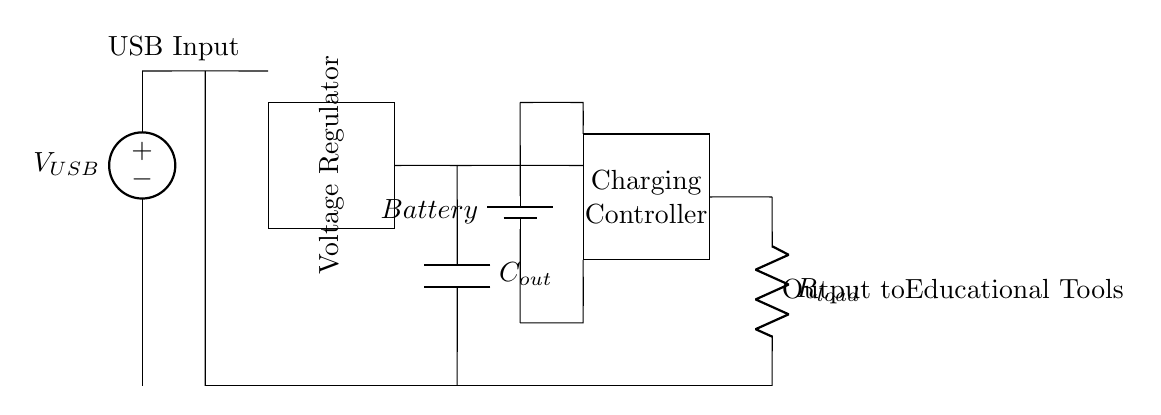What is the function of the component labeled "Voltage Regulator"? The Voltage Regulator ensures that the voltage supplied to the rest of the circuit remains constant, typically regulating it to a specific level suitable for charging or powering connected devices.
Answer: Voltage regulation What type of power source does the circuit use? The circuit uses a USB power source, which is indicated by the "USB Input" label, showing that it is designed to receive power from a USB connection.
Answer: USB How many main components are there in this charging circuit? The main components include the USB input, voltage regulator, battery, charging controller, output capacitor, and load resistor. Counting these reveals a total of five main components in the circuit.
Answer: Five What connects the output capacitor to the battery? The output capacitor is connected to the battery via the charging controller, which regulates the charging process from the capacitor to the battery.
Answer: Charging controller What is the role of the "Charging Controller"? The Charging Controller manages the charging process, controlling how current flows from the USB input and output capacitor to the battery, ensuring safe and efficient charging.
Answer: Battery management What is the relationship between the output voltage and the load resistor? The output voltage fed to the load resistor must be regulated properly so that the connected educational tools receive the correct voltage for optimal operation. The resistor indicates that the load is being powered from this output voltage.
Answer: Connected load At which part of the circuit is the output intended for educational tools drawn? The output intended for educational tools is taken from the circuit at a junction following the load resistor, showing how power is delivered to external devices.
Answer: Output to educational tools 